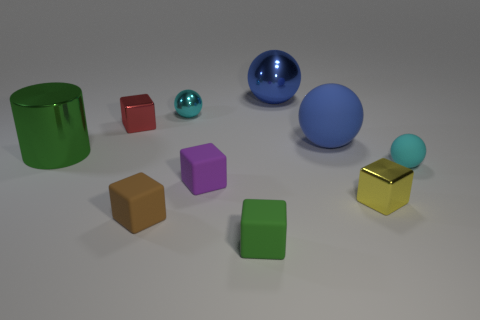Subtract all tiny red metallic blocks. How many blocks are left? 4 Subtract 2 balls. How many balls are left? 2 Subtract 1 yellow cubes. How many objects are left? 9 Subtract all spheres. How many objects are left? 6 Subtract all blue cylinders. Subtract all blue balls. How many cylinders are left? 1 Subtract all cyan cylinders. How many brown cubes are left? 1 Subtract all small yellow cubes. Subtract all green rubber cubes. How many objects are left? 8 Add 7 cyan shiny objects. How many cyan shiny objects are left? 8 Add 10 purple metallic blocks. How many purple metallic blocks exist? 10 Subtract all blue spheres. How many spheres are left? 2 